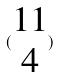<formula> <loc_0><loc_0><loc_500><loc_500>( \begin{matrix} 1 1 \\ 4 \end{matrix} )</formula> 